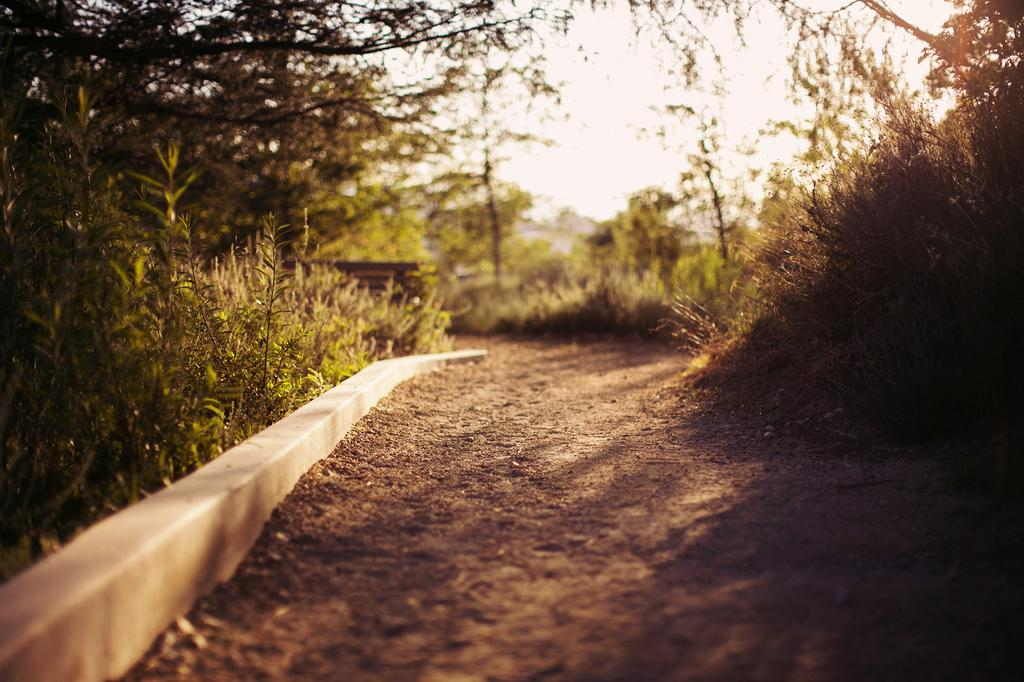What type of path is visible in the image? There is a walkway in the image. What can be seen on the left side of the image? There are trees and plants on the left side of the image. What can be seen on the right side of the image? There are trees and plants on the right side of the image. What is visible in the background of the image? The sky is visible in the background of the image. What type of liquid is being used to plough the field in the image? There is no field or plough present in the image; it features a walkway surrounded by trees and plants. 